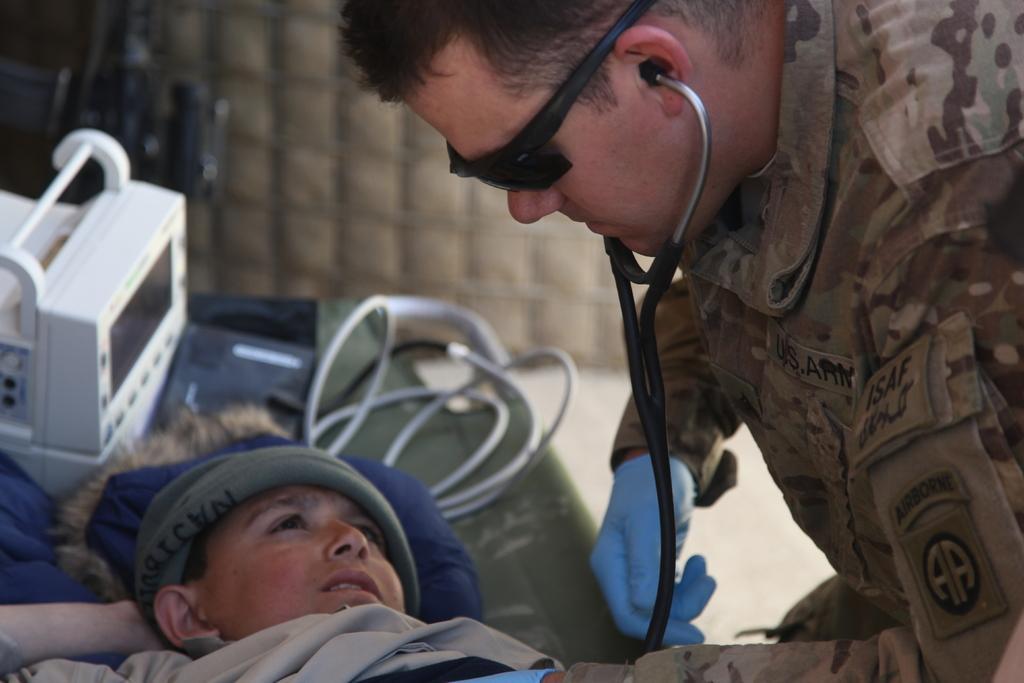Please provide a concise description of this image. In this image we can see two persons. There is a person lying on the table. There are few objects placed on the table. 